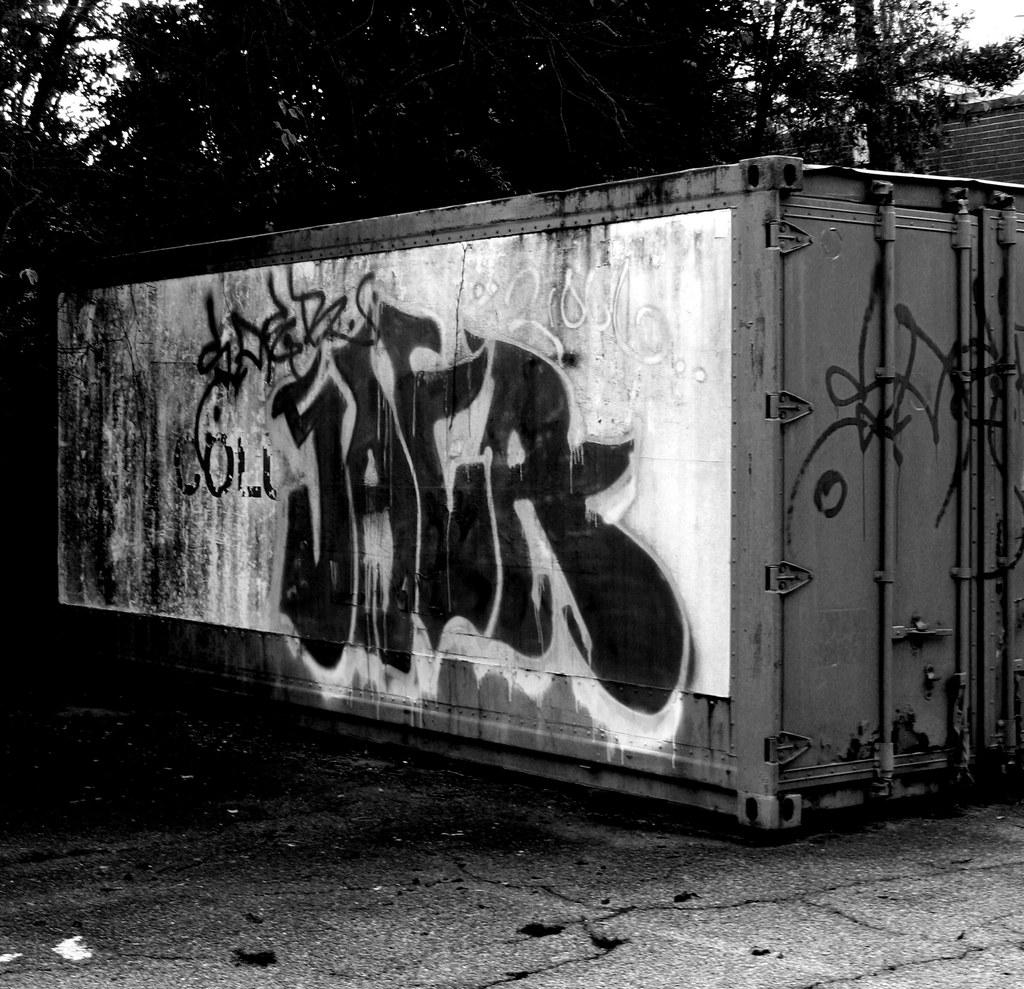What object can be seen in the image? There is a container in the image. What type of vegetation is visible at the top side of the image? There are trees at the top side of the image. What type of soup is being prepared in the container in the image? There is no soup or indication of food preparation in the image; it only features a container and trees. 